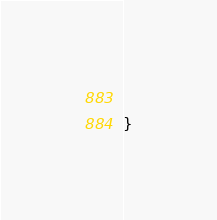Convert code to text. <code><loc_0><loc_0><loc_500><loc_500><_CSS_>  
}
</code> 